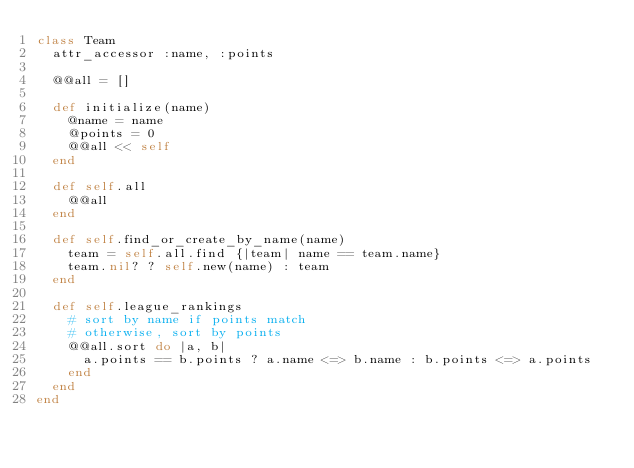Convert code to text. <code><loc_0><loc_0><loc_500><loc_500><_Ruby_>class Team
  attr_accessor :name, :points

  @@all = []

  def initialize(name)
    @name = name
    @points = 0
    @@all << self
  end

  def self.all
    @@all
  end

  def self.find_or_create_by_name(name)
    team = self.all.find {|team| name == team.name}
    team.nil? ? self.new(name) : team
  end

  def self.league_rankings
    # sort by name if points match
    # otherwise, sort by points
    @@all.sort do |a, b|
      a.points == b.points ? a.name <=> b.name : b.points <=> a.points
    end
  end
end
</code> 